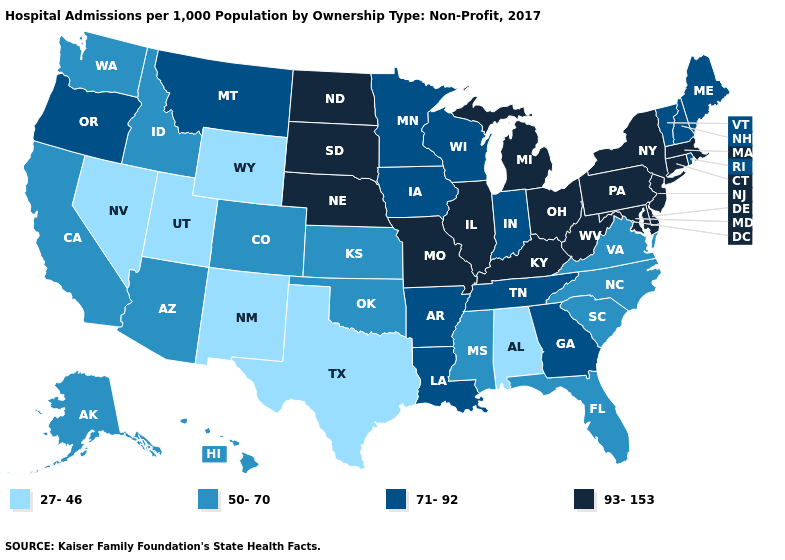What is the lowest value in states that border Tennessee?
Write a very short answer. 27-46. Name the states that have a value in the range 27-46?
Short answer required. Alabama, Nevada, New Mexico, Texas, Utah, Wyoming. Does Maine have the highest value in the USA?
Quick response, please. No. Does Utah have the lowest value in the USA?
Be succinct. Yes. What is the value of Connecticut?
Be succinct. 93-153. What is the value of Colorado?
Write a very short answer. 50-70. What is the lowest value in states that border Minnesota?
Quick response, please. 71-92. What is the value of Oregon?
Quick response, please. 71-92. Which states hav the highest value in the West?
Keep it brief. Montana, Oregon. Does Texas have the lowest value in the USA?
Short answer required. Yes. Does Vermont have the same value as Connecticut?
Write a very short answer. No. What is the value of Utah?
Concise answer only. 27-46. Name the states that have a value in the range 50-70?
Keep it brief. Alaska, Arizona, California, Colorado, Florida, Hawaii, Idaho, Kansas, Mississippi, North Carolina, Oklahoma, South Carolina, Virginia, Washington. Does Wisconsin have the highest value in the USA?
Write a very short answer. No. Among the states that border Wyoming , which have the highest value?
Keep it brief. Nebraska, South Dakota. 